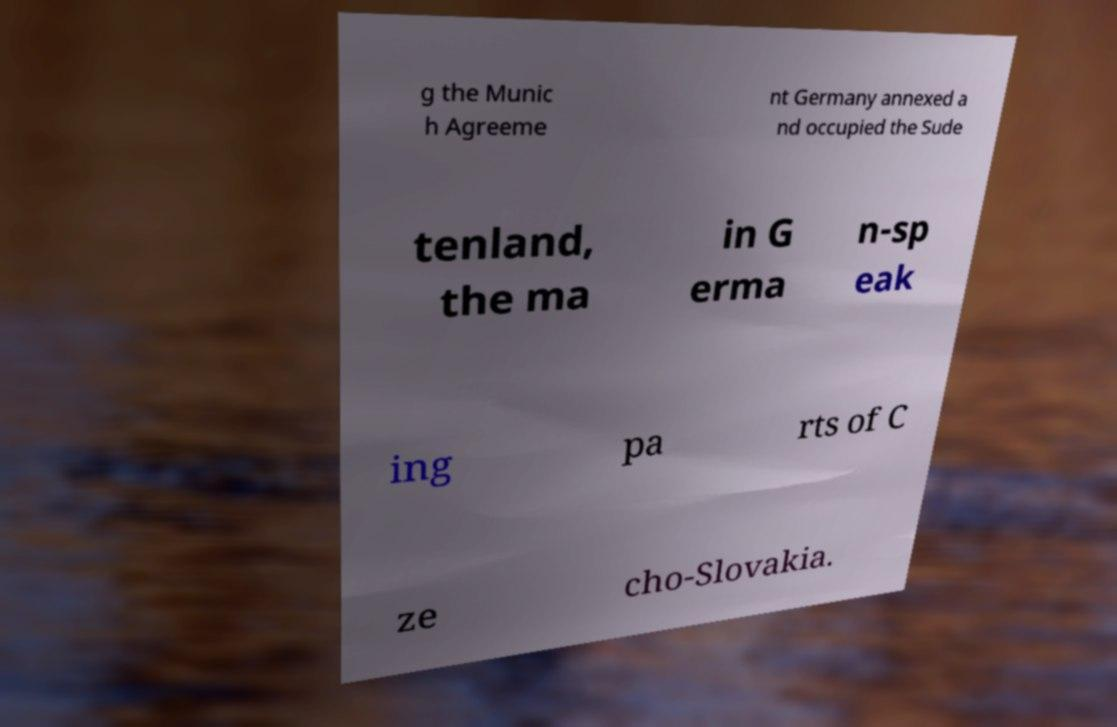For documentation purposes, I need the text within this image transcribed. Could you provide that? g the Munic h Agreeme nt Germany annexed a nd occupied the Sude tenland, the ma in G erma n-sp eak ing pa rts of C ze cho-Slovakia. 